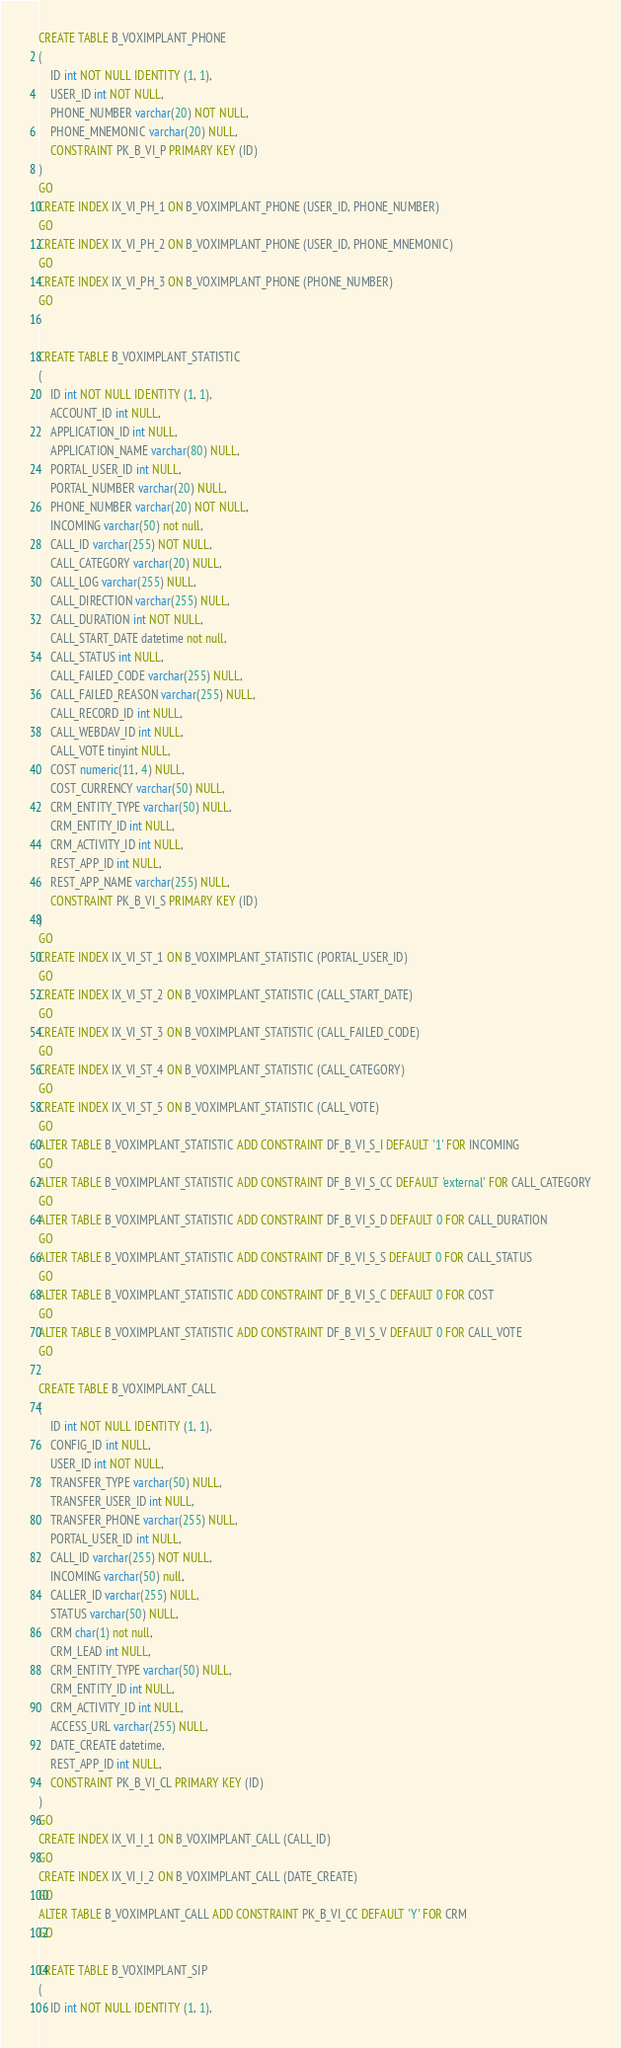<code> <loc_0><loc_0><loc_500><loc_500><_SQL_>CREATE TABLE B_VOXIMPLANT_PHONE
(
	ID int NOT NULL IDENTITY (1, 1),
	USER_ID int NOT NULL,
	PHONE_NUMBER varchar(20) NOT NULL,
	PHONE_MNEMONIC varchar(20) NULL,
	CONSTRAINT PK_B_VI_P PRIMARY KEY (ID)
)
GO
CREATE INDEX IX_VI_PH_1 ON B_VOXIMPLANT_PHONE (USER_ID, PHONE_NUMBER)
GO
CREATE INDEX IX_VI_PH_2 ON B_VOXIMPLANT_PHONE (USER_ID, PHONE_MNEMONIC)
GO
CREATE INDEX IX_VI_PH_3 ON B_VOXIMPLANT_PHONE (PHONE_NUMBER)
GO


CREATE TABLE B_VOXIMPLANT_STATISTIC
(
	ID int NOT NULL IDENTITY (1, 1),
	ACCOUNT_ID int NULL,
	APPLICATION_ID int NULL,
	APPLICATION_NAME varchar(80) NULL,
	PORTAL_USER_ID int NULL,
	PORTAL_NUMBER varchar(20) NULL,
	PHONE_NUMBER varchar(20) NOT NULL,
	INCOMING varchar(50) not null,
	CALL_ID varchar(255) NOT NULL,
	CALL_CATEGORY varchar(20) NULL,
	CALL_LOG varchar(255) NULL,
	CALL_DIRECTION varchar(255) NULL,
	CALL_DURATION int NOT NULL,
	CALL_START_DATE datetime not null,
	CALL_STATUS int NULL,
	CALL_FAILED_CODE varchar(255) NULL,
	CALL_FAILED_REASON varchar(255) NULL,
	CALL_RECORD_ID int NULL,
	CALL_WEBDAV_ID int NULL,
	CALL_VOTE tinyint NULL,
	COST numeric(11, 4) NULL,
	COST_CURRENCY varchar(50) NULL,
	CRM_ENTITY_TYPE varchar(50) NULL,
	CRM_ENTITY_ID int NULL,
	CRM_ACTIVITY_ID int NULL,
	REST_APP_ID int NULL,
	REST_APP_NAME varchar(255) NULL,
	CONSTRAINT PK_B_VI_S PRIMARY KEY (ID)
)
GO
CREATE INDEX IX_VI_ST_1 ON B_VOXIMPLANT_STATISTIC (PORTAL_USER_ID)
GO
CREATE INDEX IX_VI_ST_2 ON B_VOXIMPLANT_STATISTIC (CALL_START_DATE)
GO
CREATE INDEX IX_VI_ST_3 ON B_VOXIMPLANT_STATISTIC (CALL_FAILED_CODE)
GO
CREATE INDEX IX_VI_ST_4 ON B_VOXIMPLANT_STATISTIC (CALL_CATEGORY)
GO
CREATE INDEX IX_VI_ST_5 ON B_VOXIMPLANT_STATISTIC (CALL_VOTE)
GO
ALTER TABLE B_VOXIMPLANT_STATISTIC ADD CONSTRAINT DF_B_VI_S_I DEFAULT '1' FOR INCOMING
GO
ALTER TABLE B_VOXIMPLANT_STATISTIC ADD CONSTRAINT DF_B_VI_S_CC DEFAULT 'external' FOR CALL_CATEGORY
GO
ALTER TABLE B_VOXIMPLANT_STATISTIC ADD CONSTRAINT DF_B_VI_S_D DEFAULT 0 FOR CALL_DURATION
GO
ALTER TABLE B_VOXIMPLANT_STATISTIC ADD CONSTRAINT DF_B_VI_S_S DEFAULT 0 FOR CALL_STATUS
GO
ALTER TABLE B_VOXIMPLANT_STATISTIC ADD CONSTRAINT DF_B_VI_S_C DEFAULT 0 FOR COST
GO
ALTER TABLE B_VOXIMPLANT_STATISTIC ADD CONSTRAINT DF_B_VI_S_V DEFAULT 0 FOR CALL_VOTE
GO

CREATE TABLE B_VOXIMPLANT_CALL
(
	ID int NOT NULL IDENTITY (1, 1),
	CONFIG_ID int NULL,
	USER_ID int NOT NULL,
	TRANSFER_TYPE varchar(50) NULL,
	TRANSFER_USER_ID int NULL,
   	TRANSFER_PHONE varchar(255) NULL,
	PORTAL_USER_ID int NULL,
	CALL_ID varchar(255) NOT NULL,
	INCOMING varchar(50) null,
	CALLER_ID varchar(255) NULL,
	STATUS varchar(50) NULL,
	CRM char(1) not null,
	CRM_LEAD int NULL,
	CRM_ENTITY_TYPE varchar(50) NULL,
	CRM_ENTITY_ID int NULL,
	CRM_ACTIVITY_ID int NULL,
	ACCESS_URL varchar(255) NULL,
	DATE_CREATE datetime,
	REST_APP_ID int NULL,
	CONSTRAINT PK_B_VI_CL PRIMARY KEY (ID)
)
GO
CREATE INDEX IX_VI_I_1 ON B_VOXIMPLANT_CALL (CALL_ID)
GO
CREATE INDEX IX_VI_I_2 ON B_VOXIMPLANT_CALL (DATE_CREATE)
GO
ALTER TABLE B_VOXIMPLANT_CALL ADD CONSTRAINT PK_B_VI_CC DEFAULT 'Y' FOR CRM
GO

CREATE TABLE B_VOXIMPLANT_SIP
(
	ID int NOT NULL IDENTITY (1, 1),</code> 